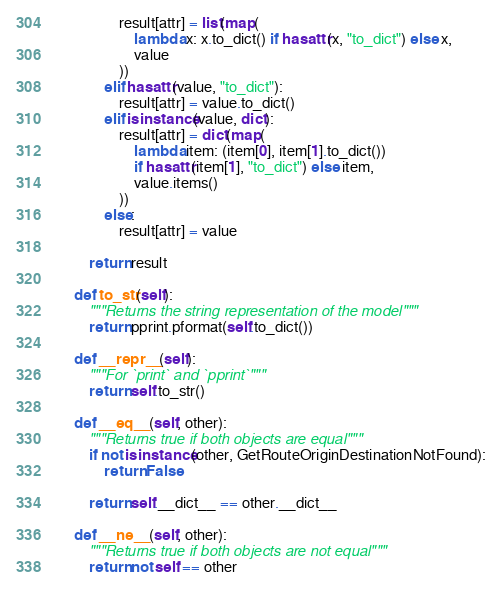<code> <loc_0><loc_0><loc_500><loc_500><_Python_>                result[attr] = list(map(
                    lambda x: x.to_dict() if hasattr(x, "to_dict") else x,
                    value
                ))
            elif hasattr(value, "to_dict"):
                result[attr] = value.to_dict()
            elif isinstance(value, dict):
                result[attr] = dict(map(
                    lambda item: (item[0], item[1].to_dict())
                    if hasattr(item[1], "to_dict") else item,
                    value.items()
                ))
            else:
                result[attr] = value

        return result

    def to_str(self):
        """Returns the string representation of the model"""
        return pprint.pformat(self.to_dict())

    def __repr__(self):
        """For `print` and `pprint`"""
        return self.to_str()

    def __eq__(self, other):
        """Returns true if both objects are equal"""
        if not isinstance(other, GetRouteOriginDestinationNotFound):
            return False

        return self.__dict__ == other.__dict__

    def __ne__(self, other):
        """Returns true if both objects are not equal"""
        return not self == other
</code> 